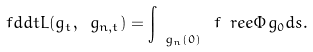<formula> <loc_0><loc_0><loc_500><loc_500>\ f d { d t } L ( g _ { t } , \ g _ { n , t } ) = \int _ { \ g _ { n } ( 0 ) } \ f { \ r e e \Phi } { g _ { 0 } } d s .</formula> 